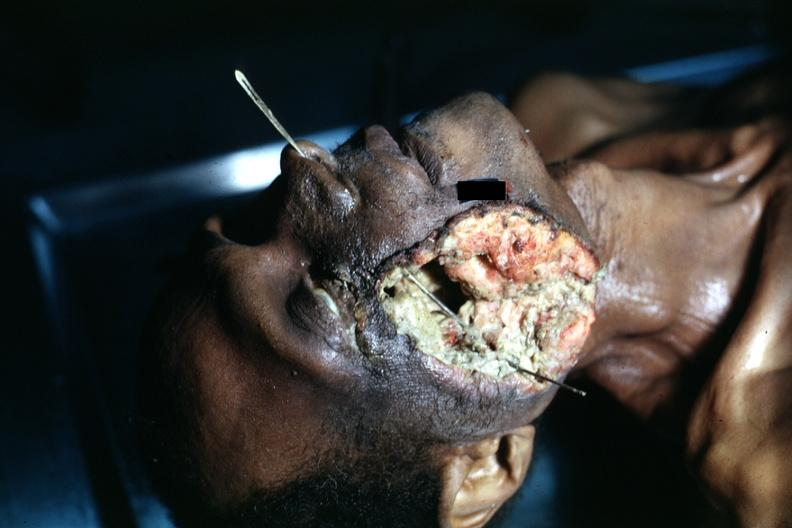s tumor grew to outside?
Answer the question using a single word or phrase. Yes 